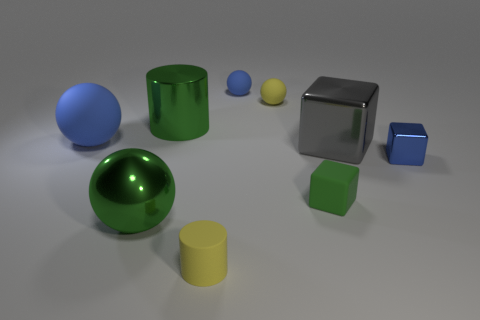Is the shape of the large blue thing the same as the yellow matte object behind the big green sphere? yes 